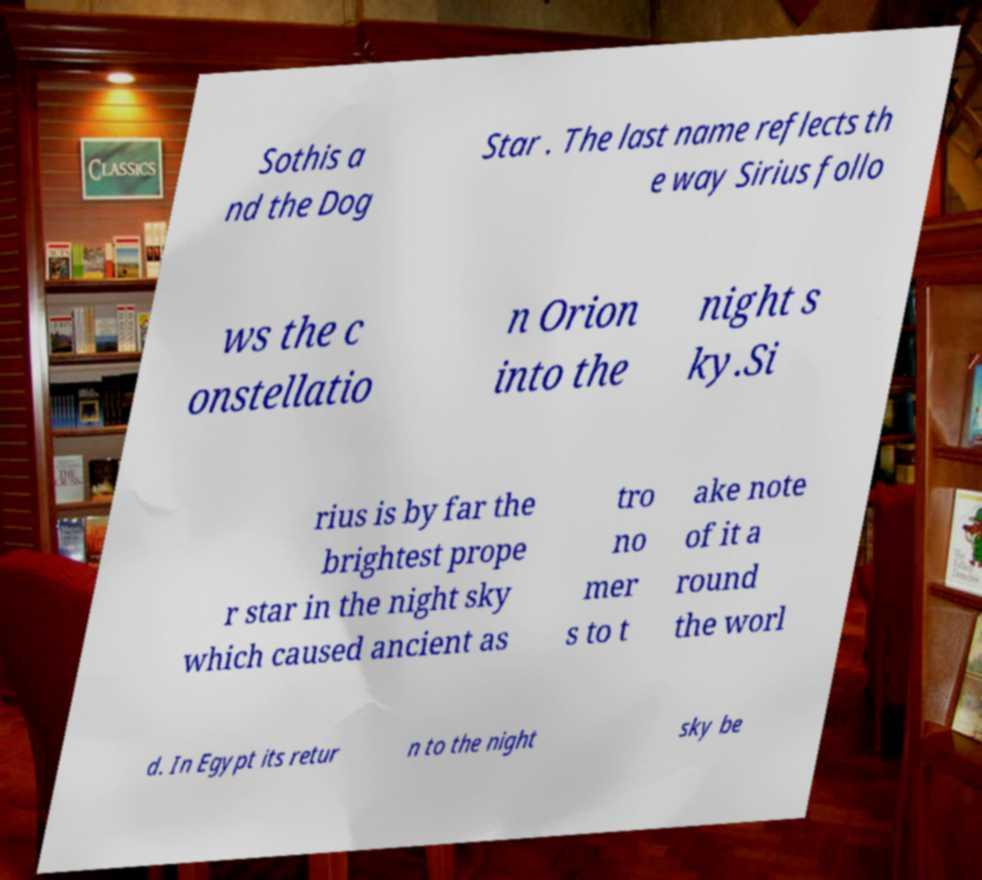Can you accurately transcribe the text from the provided image for me? Sothis a nd the Dog Star . The last name reflects th e way Sirius follo ws the c onstellatio n Orion into the night s ky.Si rius is by far the brightest prope r star in the night sky which caused ancient as tro no mer s to t ake note of it a round the worl d. In Egypt its retur n to the night sky be 